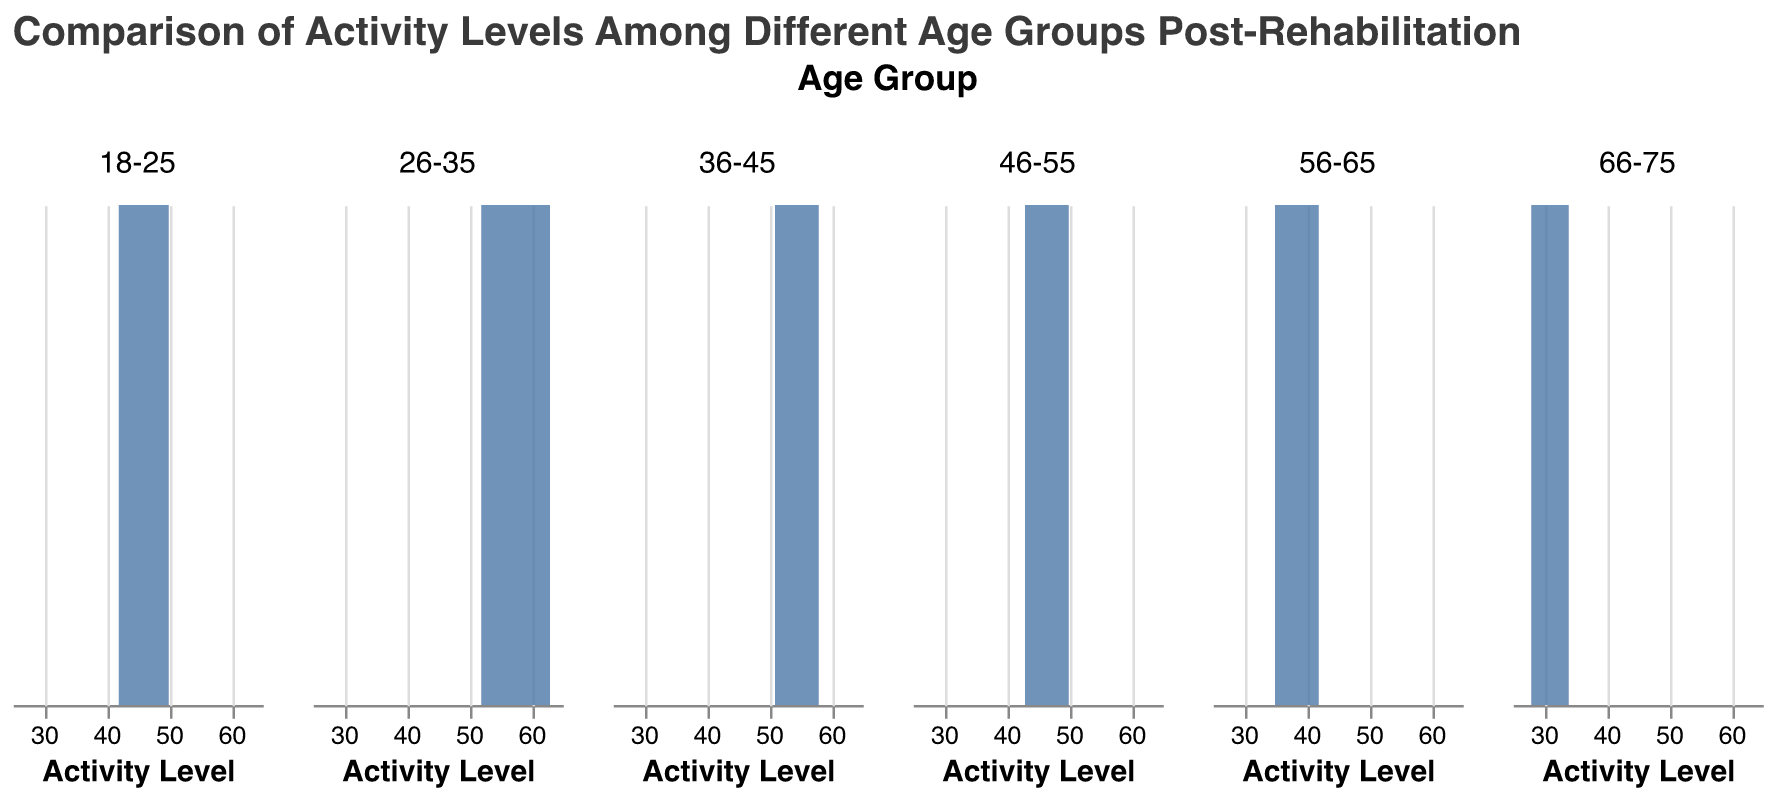What is the title of the plot? The title of the plot is written at the top in a larger, bold font and indicates the main focus of the chart.
Answer: Comparison of Activity Levels Among Different Age Groups Post-Rehabilitation What age group has the highest peak density in terms of post-rehab activity levels? To find the age group with the highest peak density, look for the subplot where the density curve reaches the highest y-value.
Answer: 26-35 Which age group shows the lowest range of post-rehab activity levels? Identify the subplot where the curve is the narrowest along the x-axis; this indicates a smaller range of activity levels.
Answer: 66-75 Are the post-rehab activity levels for the age group 18-25 higher or lower than those for 56-65? Compare the density plots for 18-25 and 56-65: if the range of the 18-25 group is consistently to the right of the 56-65 group, it is higher; if to the left, it is lower.
Answer: Higher Which age group displays the widest range of post-rehab activity levels? Look for the age group subplot where the density curve extends the furthest along the x-axis, indicating a wider range of activity levels.
Answer: 26-35 What's the median value of the post-rehab activity level for the age group 36-45? Identify the center of the density plot for the age group 36-45. The median corresponds to the x-value at the peak or midpoint of the highest density.
Answer: Around 54 How do the activity levels of the age group 46-55 compare to the activity levels of the age group 66-75? Compare the x-axis ranges of the density plots for the two age groups; if they largely overlap, the activity levels are similar, otherwise, note which group has higher or lower levels.
Answer: Higher Which age group shows the most consistent post-rehab activity levels (i.e., least variance)? Look for the narrowest, tallest peak in the density plot, indicating less spread around a common activity level.
Answer: 66-75 How does the density curve for age group 56-65 look compared to the others in terms of skewness? Examine the shape of the density curve: if it tails off to one side more than the other, it's skewed. Compare its shape to the other age groups.
Answer: Left-skewed What can be inferred about activity levels for the age group 26-35 based on the plot? The density curve shows a high, broad peak indicating a higher and wide range of activity levels, with most data points centered around higher activity values.
Answer: Higher and broad range 